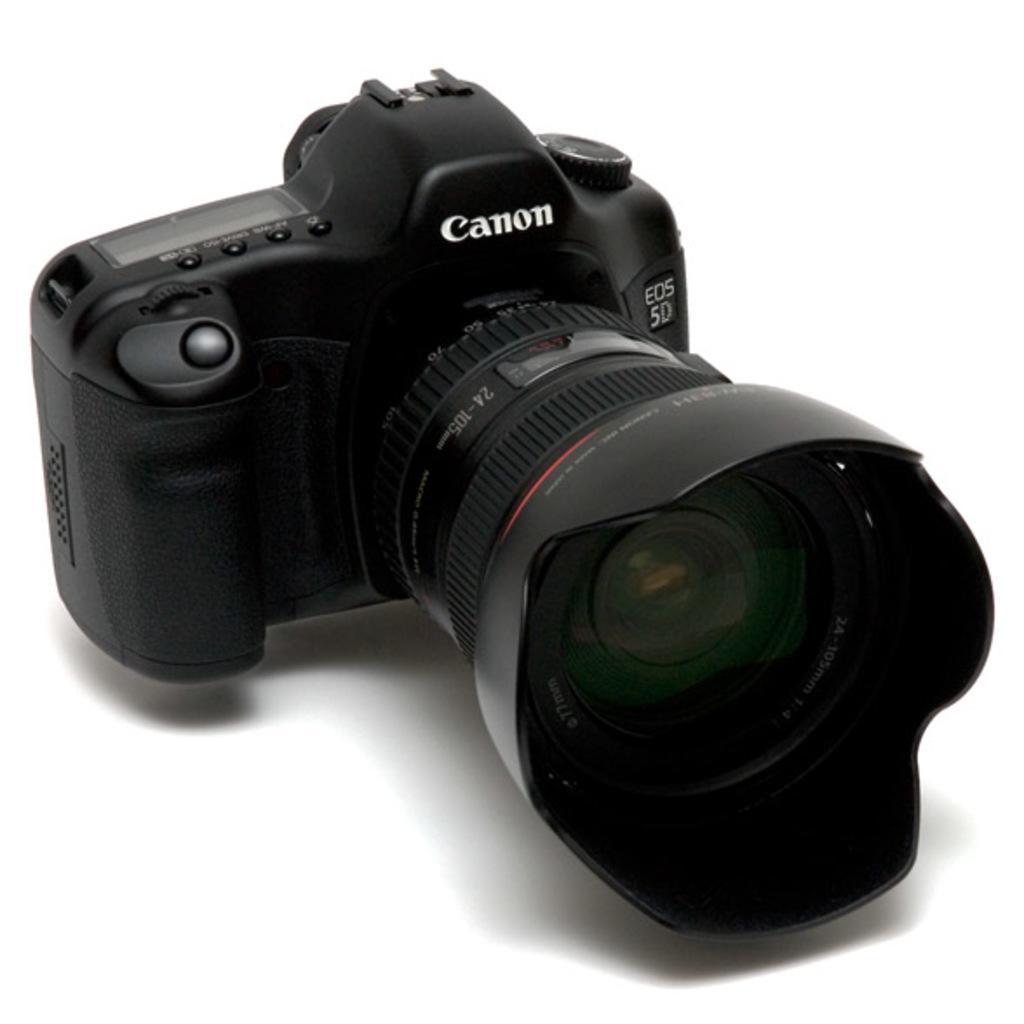Describe this image in one or two sentences. In this image we can see a camera which is placed on the surface. 